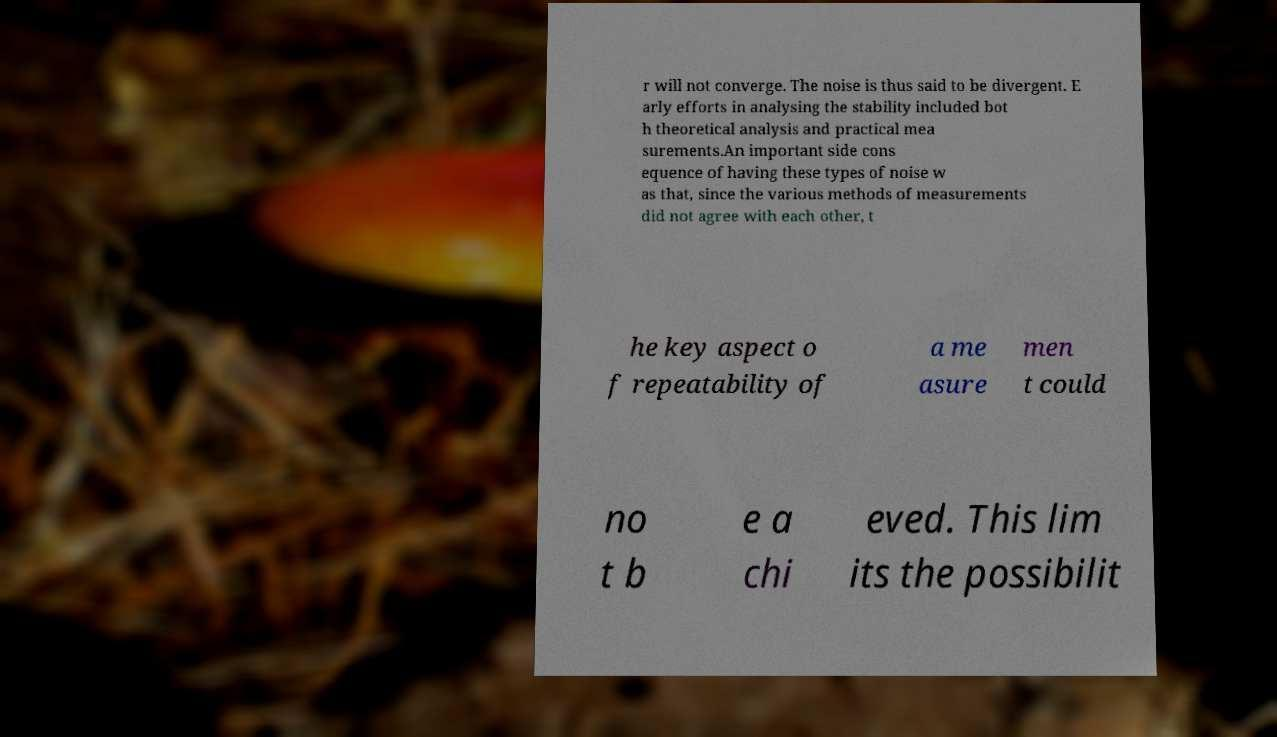Can you accurately transcribe the text from the provided image for me? r will not converge. The noise is thus said to be divergent. E arly efforts in analysing the stability included bot h theoretical analysis and practical mea surements.An important side cons equence of having these types of noise w as that, since the various methods of measurements did not agree with each other, t he key aspect o f repeatability of a me asure men t could no t b e a chi eved. This lim its the possibilit 